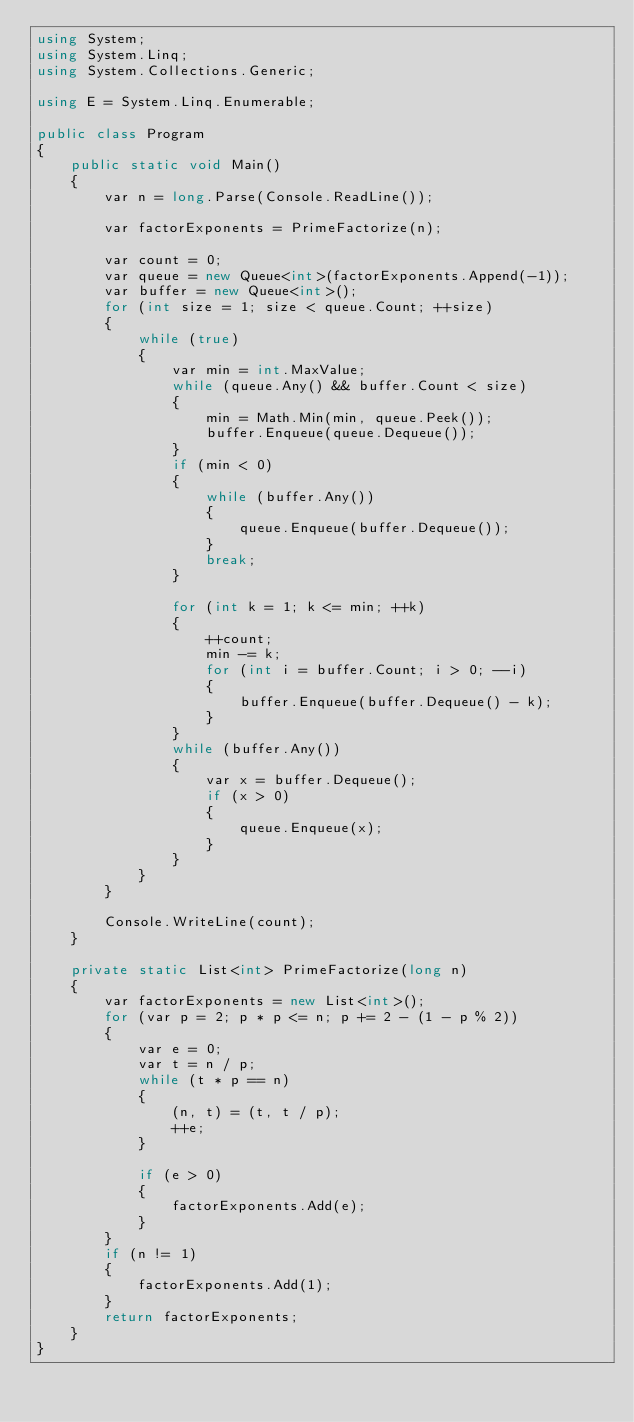Convert code to text. <code><loc_0><loc_0><loc_500><loc_500><_C#_>using System;
using System.Linq;
using System.Collections.Generic;

using E = System.Linq.Enumerable;

public class Program
{
    public static void Main()
    {
        var n = long.Parse(Console.ReadLine());

        var factorExponents = PrimeFactorize(n);

        var count = 0;
        var queue = new Queue<int>(factorExponents.Append(-1));
        var buffer = new Queue<int>();
        for (int size = 1; size < queue.Count; ++size)
        {
            while (true)
            {
                var min = int.MaxValue;
                while (queue.Any() && buffer.Count < size)
                {
                    min = Math.Min(min, queue.Peek());
                    buffer.Enqueue(queue.Dequeue());
                }
                if (min < 0)
                {
                    while (buffer.Any())
                    {
                        queue.Enqueue(buffer.Dequeue());
                    }
                    break;
                }

                for (int k = 1; k <= min; ++k)
                {
                    ++count;
                    min -= k;
                    for (int i = buffer.Count; i > 0; --i)
                    {
                        buffer.Enqueue(buffer.Dequeue() - k);
                    }
                }
                while (buffer.Any())
                {
                    var x = buffer.Dequeue();
                    if (x > 0)
                    {
                        queue.Enqueue(x);
                    }
                }
            }
        }

        Console.WriteLine(count);
    }

    private static List<int> PrimeFactorize(long n)
    {
        var factorExponents = new List<int>();
        for (var p = 2; p * p <= n; p += 2 - (1 - p % 2))
        {
            var e = 0;
            var t = n / p;
            while (t * p == n)
            {
                (n, t) = (t, t / p);
                ++e;
            }

            if (e > 0)
            {
                factorExponents.Add(e);
            }
        }
        if (n != 1)
        {
            factorExponents.Add(1);
        }
        return factorExponents;
    }
}
</code> 